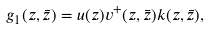Convert formula to latex. <formula><loc_0><loc_0><loc_500><loc_500>g _ { 1 } ( z , \bar { z } ) = u ( z ) v ^ { + } ( z , \bar { z } ) k ( z , \bar { z } ) ,</formula> 